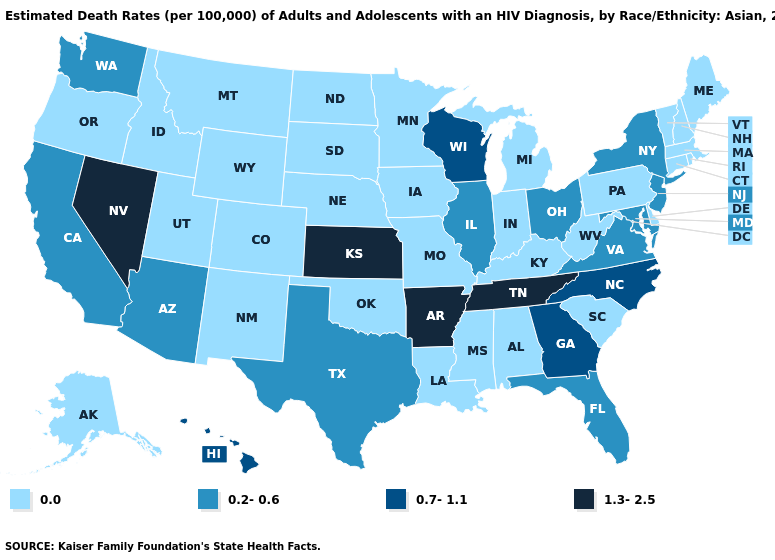Name the states that have a value in the range 1.3-2.5?
Answer briefly. Arkansas, Kansas, Nevada, Tennessee. What is the highest value in the Northeast ?
Concise answer only. 0.2-0.6. How many symbols are there in the legend?
Concise answer only. 4. Does the map have missing data?
Concise answer only. No. Does Maryland have a lower value than Hawaii?
Short answer required. Yes. Does the first symbol in the legend represent the smallest category?
Answer briefly. Yes. Does Georgia have the lowest value in the USA?
Keep it brief. No. What is the value of Kansas?
Be succinct. 1.3-2.5. What is the highest value in states that border Wisconsin?
Be succinct. 0.2-0.6. Which states have the lowest value in the USA?
Concise answer only. Alabama, Alaska, Colorado, Connecticut, Delaware, Idaho, Indiana, Iowa, Kentucky, Louisiana, Maine, Massachusetts, Michigan, Minnesota, Mississippi, Missouri, Montana, Nebraska, New Hampshire, New Mexico, North Dakota, Oklahoma, Oregon, Pennsylvania, Rhode Island, South Carolina, South Dakota, Utah, Vermont, West Virginia, Wyoming. Is the legend a continuous bar?
Concise answer only. No. Name the states that have a value in the range 1.3-2.5?
Concise answer only. Arkansas, Kansas, Nevada, Tennessee. Is the legend a continuous bar?
Give a very brief answer. No. Does the first symbol in the legend represent the smallest category?
Give a very brief answer. Yes. 